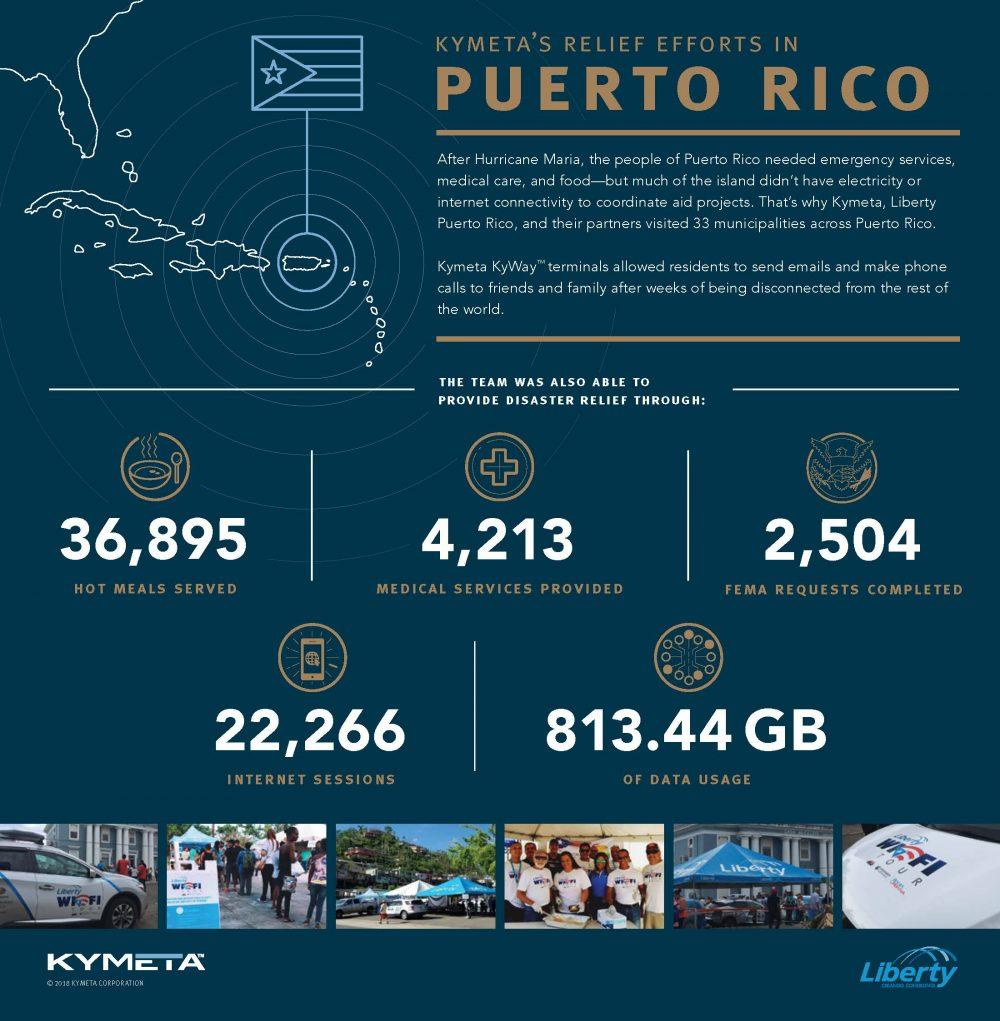List a handful of essential elements in this visual. In total, 2,504 FEMA requests were completed. During the relief operations, a total of 4,213 medical services were provided by the team. The report indicates that a total of 22,266 internet sessions were enabled. The relief team enabled a total of 813.44 GB of data usage. In total, 36,895 hot meals were served. 